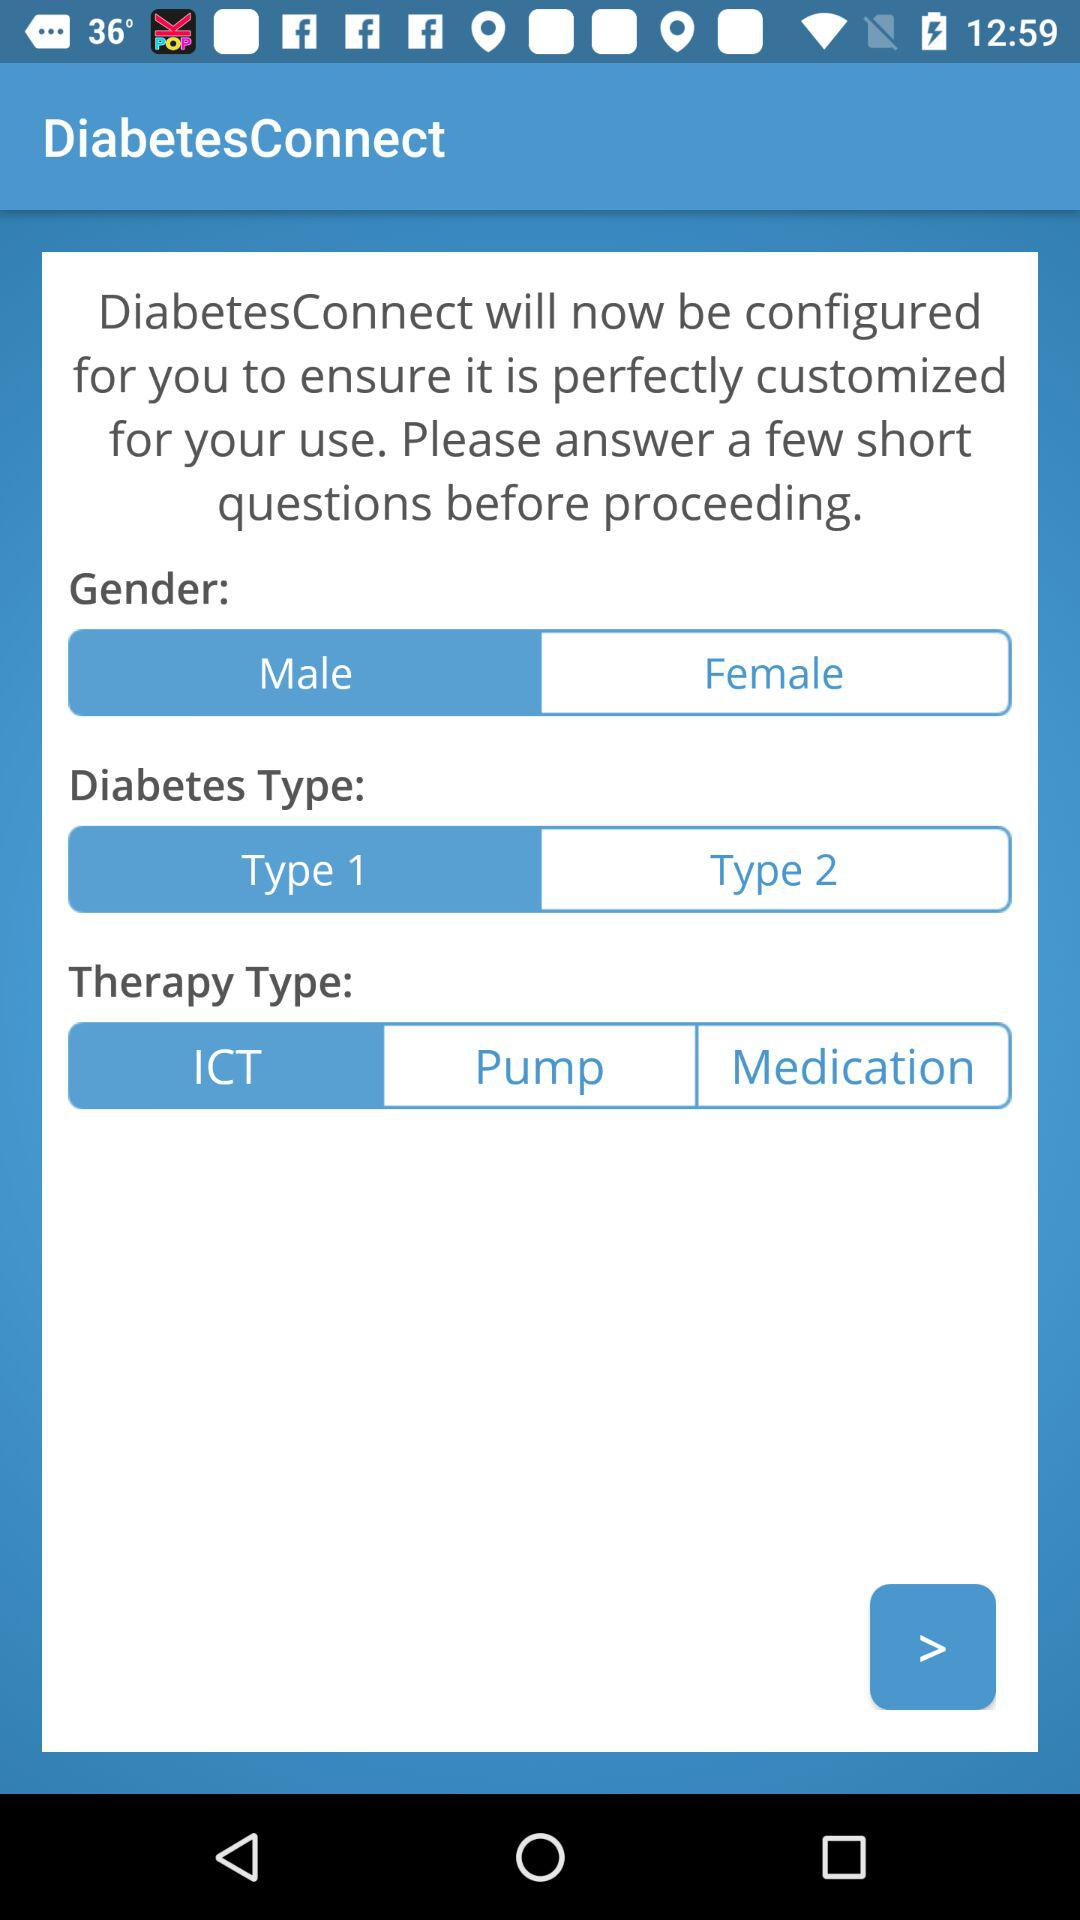What's the type of therapy? The type of therapy is "ICT". 